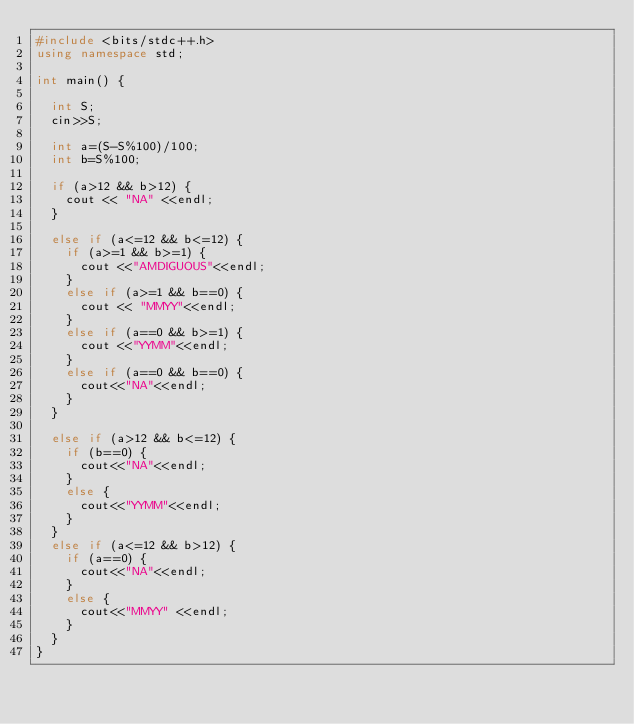Convert code to text. <code><loc_0><loc_0><loc_500><loc_500><_C++_>#include <bits/stdc++.h>
using namespace std;

int main() {
  
  int S;
  cin>>S;
  
  int a=(S-S%100)/100;
  int b=S%100;

  if (a>12 && b>12) {
    cout << "NA" <<endl;
  }
  
  else if (a<=12 && b<=12) {
    if (a>=1 && b>=1) {
      cout <<"AMDIGUOUS"<<endl;
    }
    else if (a>=1 && b==0) {
      cout << "MMYY"<<endl;
    }
    else if (a==0 && b>=1) {
      cout <<"YYMM"<<endl;
    }
    else if (a==0 && b==0) {
      cout<<"NA"<<endl;
    }
  }
  
  else if (a>12 && b<=12) {
    if (b==0) {
      cout<<"NA"<<endl;
    }
    else {
      cout<<"YYMM"<<endl;
    }
  }
  else if (a<=12 && b>12) {
    if (a==0) {
      cout<<"NA"<<endl;
    }
    else {
      cout<<"MMYY" <<endl;
    }
  }
}</code> 